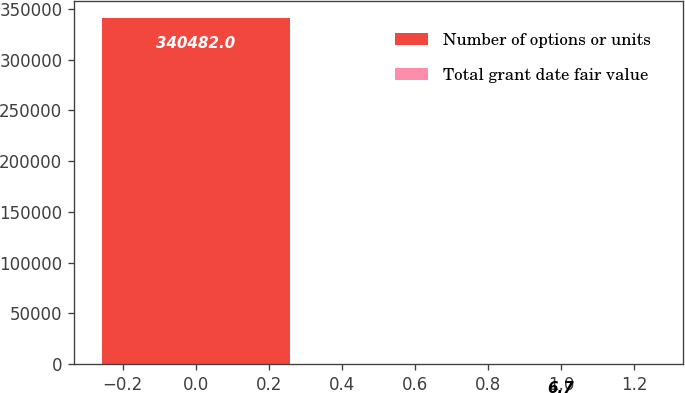Convert chart to OTSL. <chart><loc_0><loc_0><loc_500><loc_500><bar_chart><fcel>Number of options or units<fcel>Total grant date fair value<nl><fcel>340482<fcel>6.7<nl></chart> 